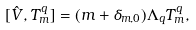Convert formula to latex. <formula><loc_0><loc_0><loc_500><loc_500>[ \hat { V } , T ^ { q } _ { m } ] = ( m + \delta _ { m , 0 } ) \Lambda _ { q } T ^ { q } _ { m } ,</formula> 